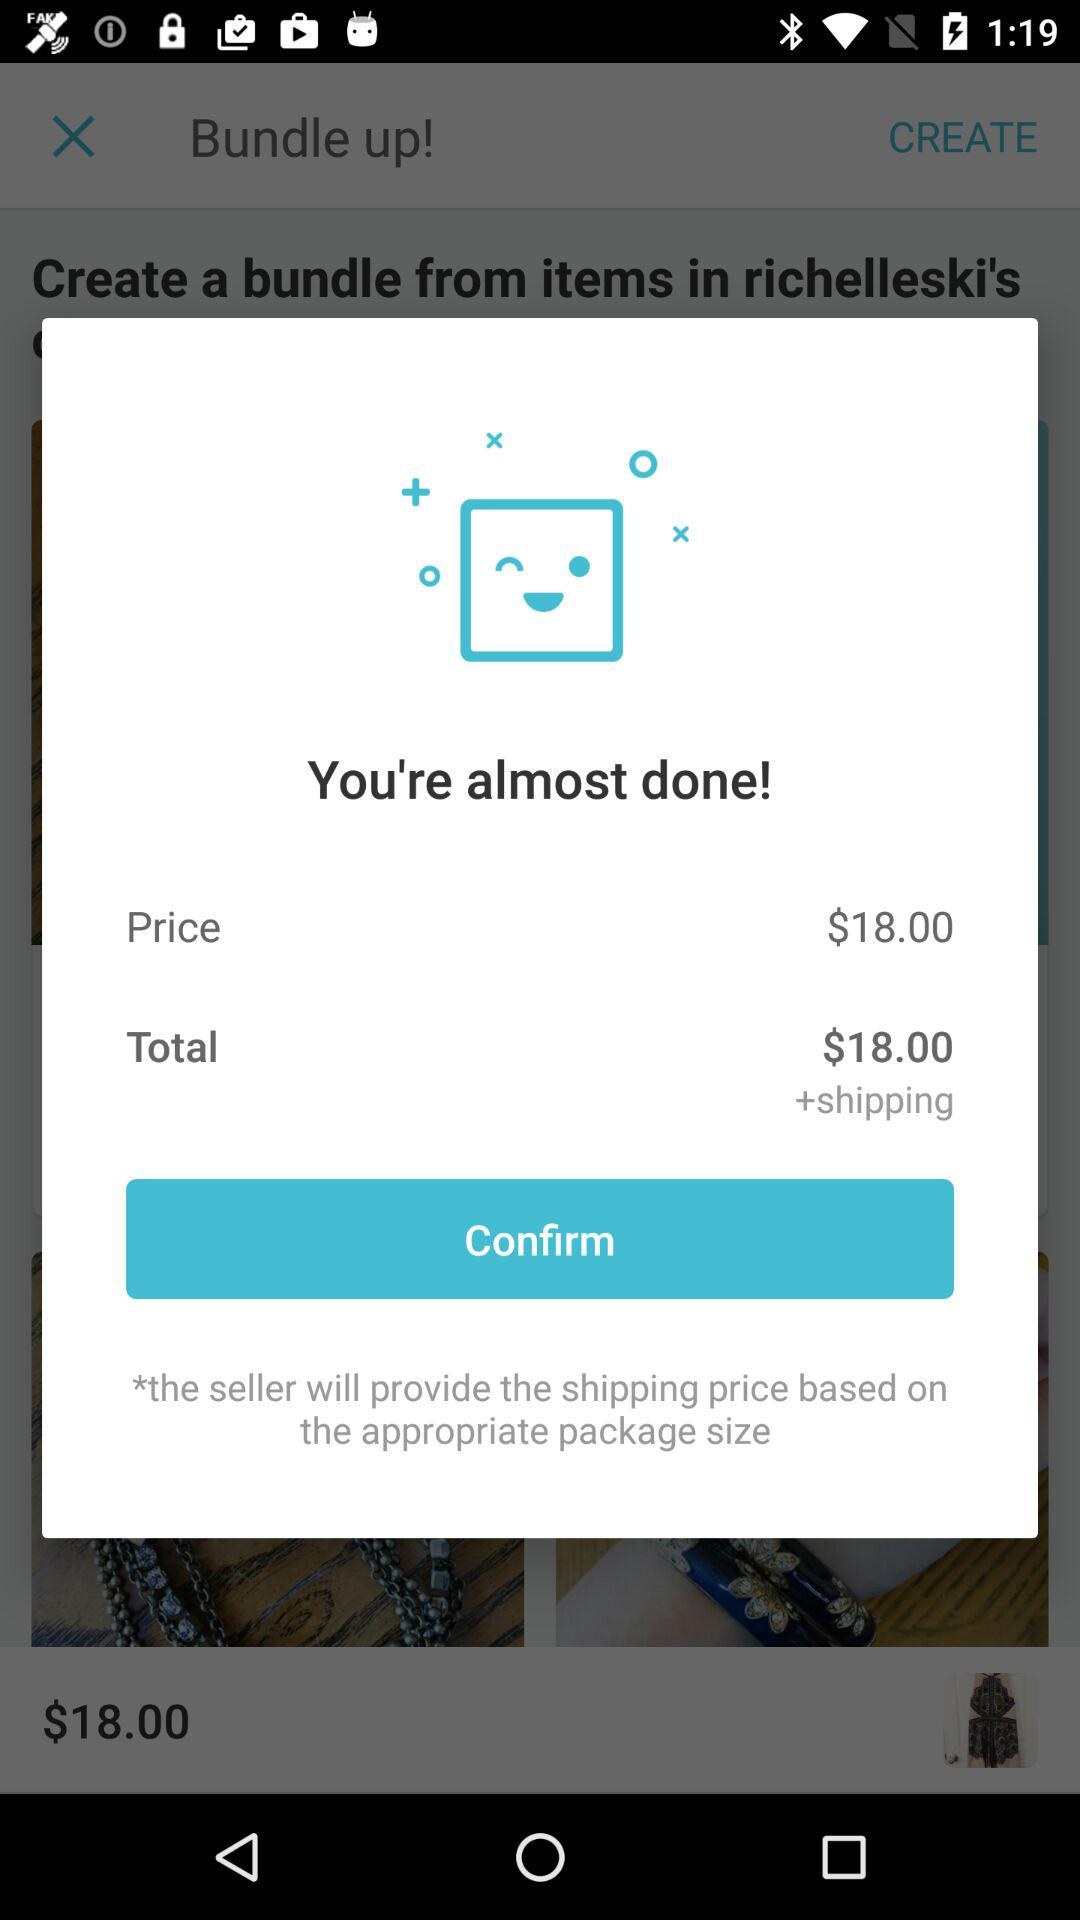What is the total price of the order?
Answer the question using a single word or phrase. $18.00 